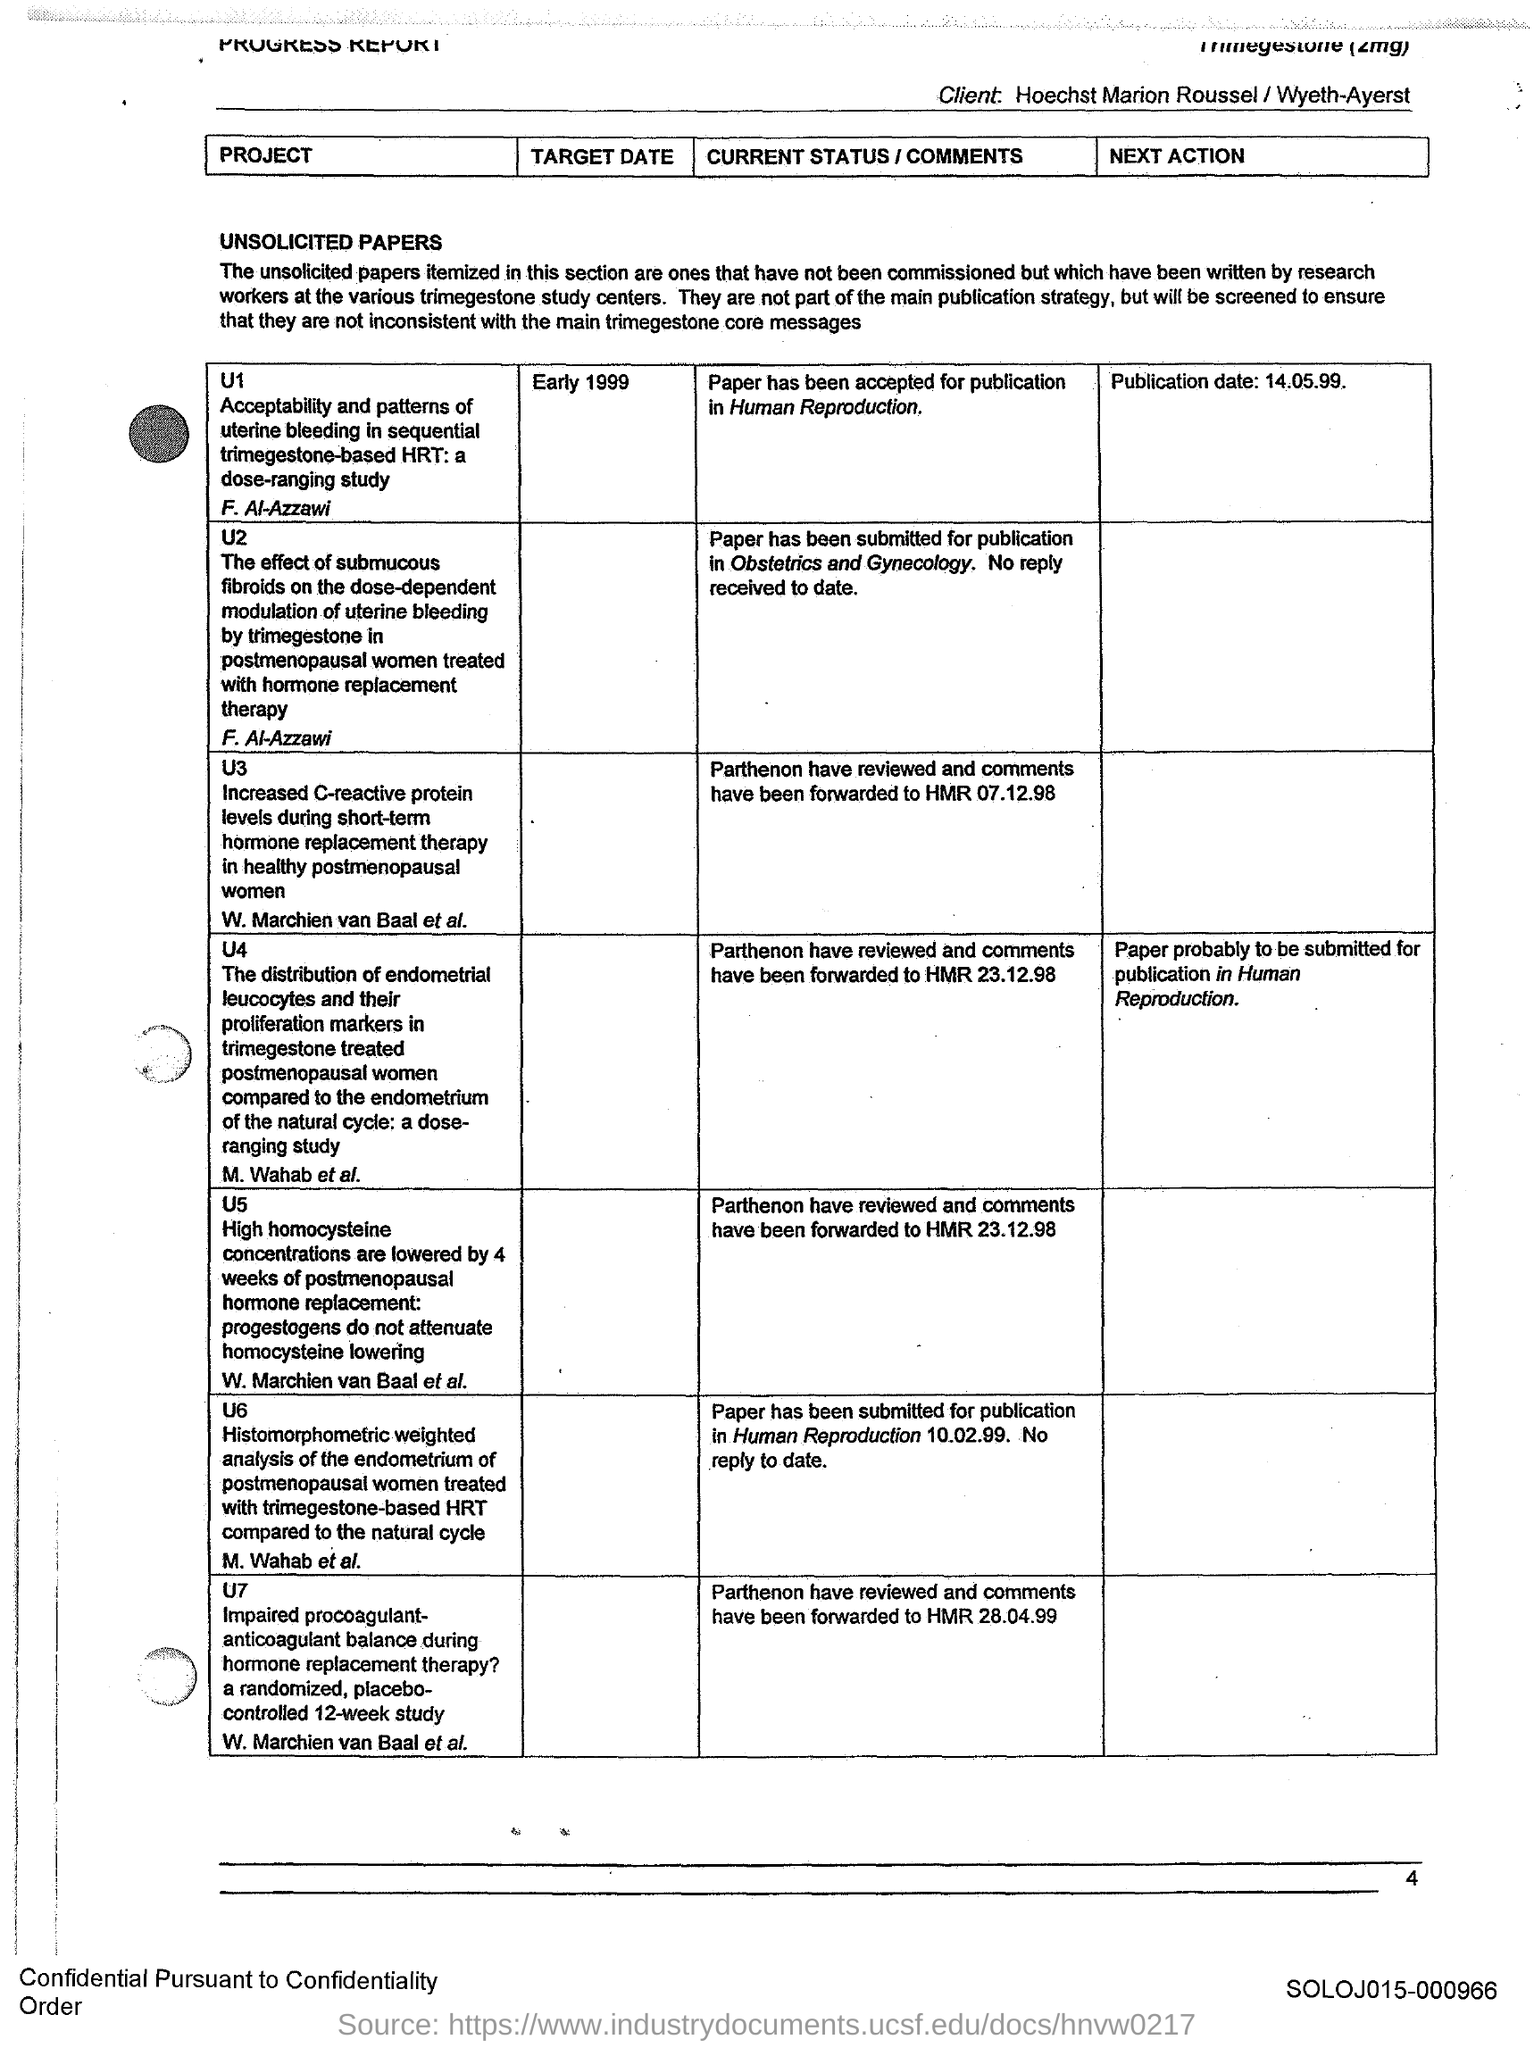What is the Page Number?
Your answer should be very brief. 4. What is the Publication date of project U1?
Your answer should be compact. 14.05.99. What is the target date of the project U1?
Provide a succinct answer. Early 1999. 